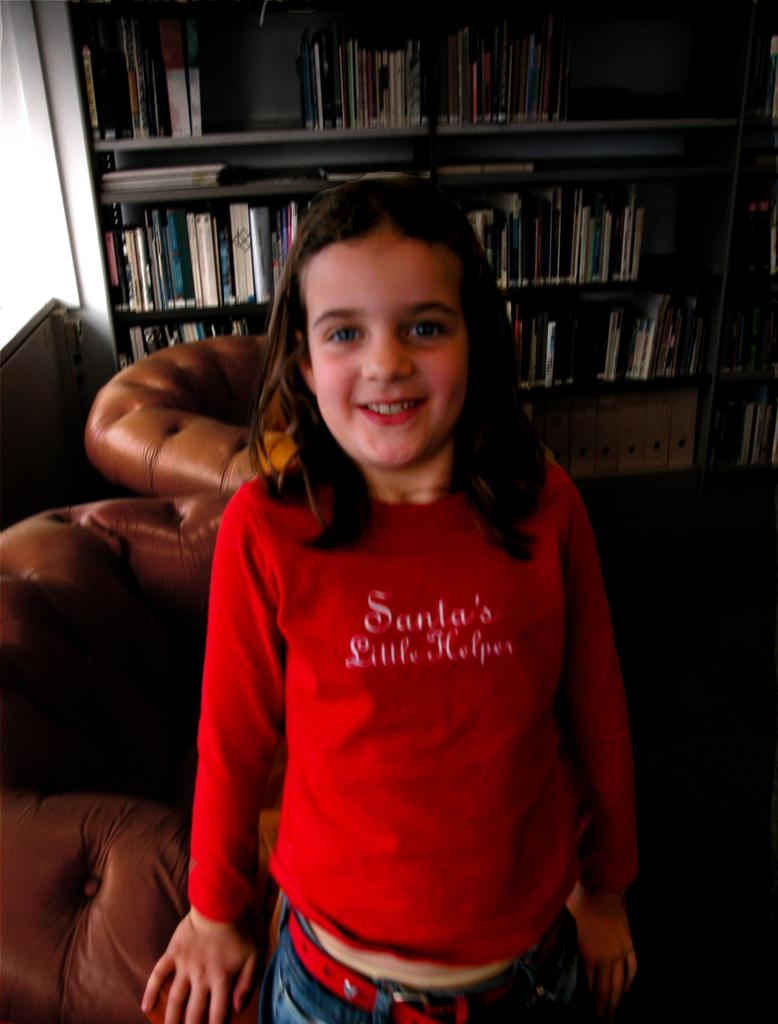<image>
Create a compact narrative representing the image presented. A young girl wearing a Santa's Little Helpers shirt. 